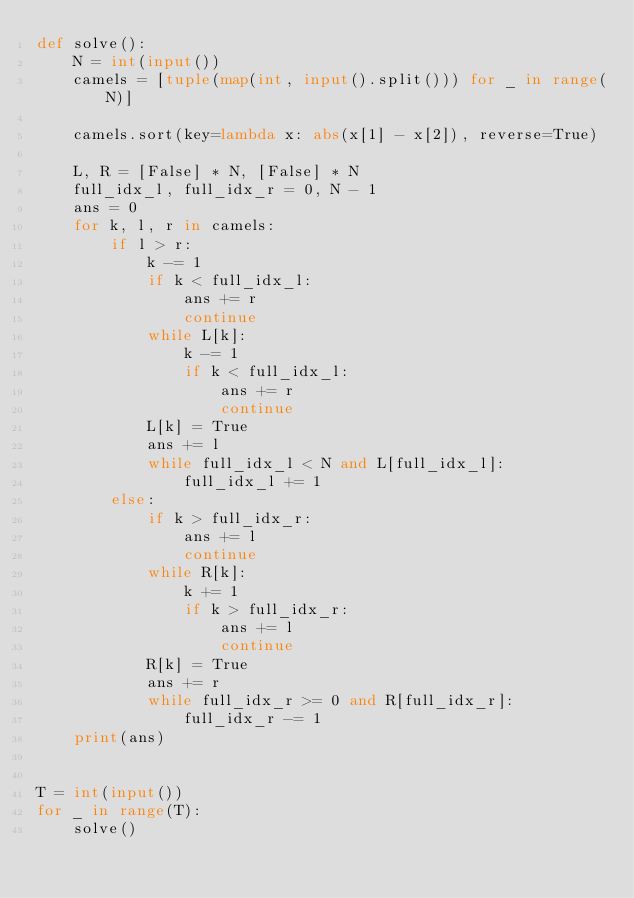Convert code to text. <code><loc_0><loc_0><loc_500><loc_500><_Python_>def solve():
    N = int(input())
    camels = [tuple(map(int, input().split())) for _ in range(N)]

    camels.sort(key=lambda x: abs(x[1] - x[2]), reverse=True)

    L, R = [False] * N, [False] * N
    full_idx_l, full_idx_r = 0, N - 1
    ans = 0
    for k, l, r in camels:
        if l > r:
            k -= 1
            if k < full_idx_l:
                ans += r
                continue
            while L[k]:
                k -= 1
                if k < full_idx_l:
                    ans += r
                    continue
            L[k] = True
            ans += l
            while full_idx_l < N and L[full_idx_l]:
                full_idx_l += 1
        else:
            if k > full_idx_r:
                ans += l
                continue
            while R[k]:
                k += 1
                if k > full_idx_r:
                    ans += l
                    continue
            R[k] = True
            ans += r
            while full_idx_r >= 0 and R[full_idx_r]:
                full_idx_r -= 1
    print(ans)


T = int(input())
for _ in range(T):
    solve()
</code> 